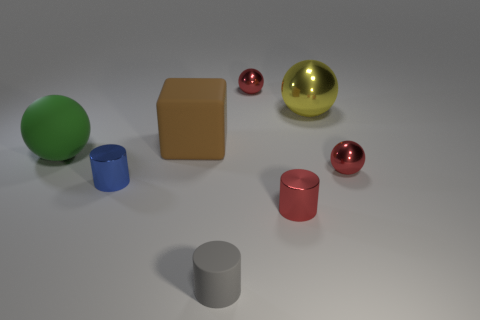Subtract 1 cylinders. How many cylinders are left? 2 Subtract all brown spheres. Subtract all purple cylinders. How many spheres are left? 4 Add 1 cyan blocks. How many objects exist? 9 Subtract all cubes. How many objects are left? 7 Add 3 large green metallic balls. How many large green metallic balls exist? 3 Subtract 0 green cylinders. How many objects are left? 8 Subtract all metal things. Subtract all small red metal objects. How many objects are left? 0 Add 7 brown cubes. How many brown cubes are left? 8 